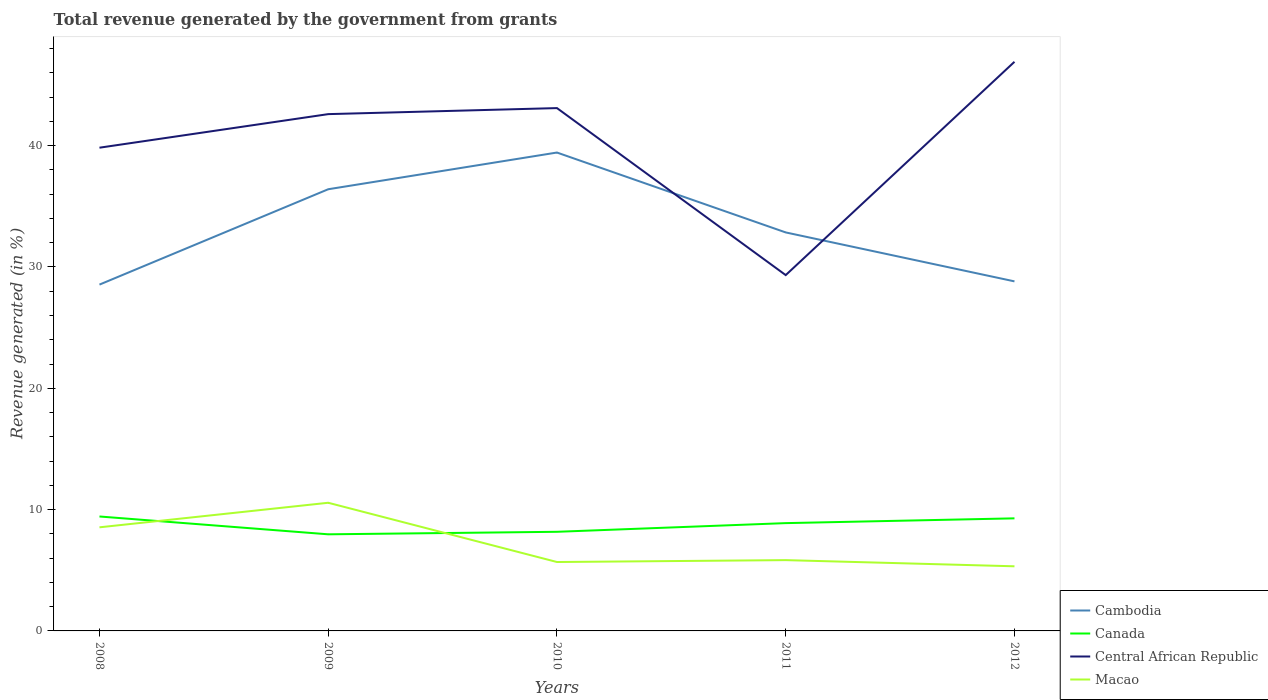Is the number of lines equal to the number of legend labels?
Give a very brief answer. Yes. Across all years, what is the maximum total revenue generated in Macao?
Provide a short and direct response. 5.33. What is the total total revenue generated in Macao in the graph?
Provide a succinct answer. 2.7. What is the difference between the highest and the second highest total revenue generated in Macao?
Your answer should be very brief. 5.24. What is the difference between the highest and the lowest total revenue generated in Cambodia?
Make the answer very short. 2. Is the total revenue generated in Central African Republic strictly greater than the total revenue generated in Canada over the years?
Offer a terse response. No. How many lines are there?
Your answer should be compact. 4. How many years are there in the graph?
Your response must be concise. 5. Are the values on the major ticks of Y-axis written in scientific E-notation?
Make the answer very short. No. Does the graph contain any zero values?
Ensure brevity in your answer.  No. Where does the legend appear in the graph?
Offer a terse response. Bottom right. What is the title of the graph?
Keep it short and to the point. Total revenue generated by the government from grants. What is the label or title of the X-axis?
Give a very brief answer. Years. What is the label or title of the Y-axis?
Ensure brevity in your answer.  Revenue generated (in %). What is the Revenue generated (in %) of Cambodia in 2008?
Your answer should be very brief. 28.55. What is the Revenue generated (in %) in Canada in 2008?
Provide a succinct answer. 9.43. What is the Revenue generated (in %) of Central African Republic in 2008?
Keep it short and to the point. 39.83. What is the Revenue generated (in %) in Macao in 2008?
Make the answer very short. 8.54. What is the Revenue generated (in %) of Cambodia in 2009?
Offer a terse response. 36.41. What is the Revenue generated (in %) in Canada in 2009?
Your response must be concise. 7.96. What is the Revenue generated (in %) of Central African Republic in 2009?
Offer a terse response. 42.6. What is the Revenue generated (in %) of Macao in 2009?
Give a very brief answer. 10.56. What is the Revenue generated (in %) in Cambodia in 2010?
Give a very brief answer. 39.43. What is the Revenue generated (in %) in Canada in 2010?
Give a very brief answer. 8.17. What is the Revenue generated (in %) in Central African Republic in 2010?
Keep it short and to the point. 43.1. What is the Revenue generated (in %) in Macao in 2010?
Keep it short and to the point. 5.68. What is the Revenue generated (in %) of Cambodia in 2011?
Keep it short and to the point. 32.85. What is the Revenue generated (in %) of Canada in 2011?
Provide a short and direct response. 8.89. What is the Revenue generated (in %) in Central African Republic in 2011?
Ensure brevity in your answer.  29.33. What is the Revenue generated (in %) of Macao in 2011?
Your answer should be compact. 5.84. What is the Revenue generated (in %) in Cambodia in 2012?
Provide a short and direct response. 28.81. What is the Revenue generated (in %) in Canada in 2012?
Make the answer very short. 9.28. What is the Revenue generated (in %) in Central African Republic in 2012?
Offer a very short reply. 46.91. What is the Revenue generated (in %) of Macao in 2012?
Provide a short and direct response. 5.33. Across all years, what is the maximum Revenue generated (in %) in Cambodia?
Provide a succinct answer. 39.43. Across all years, what is the maximum Revenue generated (in %) in Canada?
Ensure brevity in your answer.  9.43. Across all years, what is the maximum Revenue generated (in %) in Central African Republic?
Offer a very short reply. 46.91. Across all years, what is the maximum Revenue generated (in %) in Macao?
Keep it short and to the point. 10.56. Across all years, what is the minimum Revenue generated (in %) in Cambodia?
Offer a very short reply. 28.55. Across all years, what is the minimum Revenue generated (in %) of Canada?
Ensure brevity in your answer.  7.96. Across all years, what is the minimum Revenue generated (in %) of Central African Republic?
Offer a terse response. 29.33. Across all years, what is the minimum Revenue generated (in %) of Macao?
Your answer should be compact. 5.33. What is the total Revenue generated (in %) of Cambodia in the graph?
Provide a succinct answer. 166.05. What is the total Revenue generated (in %) in Canada in the graph?
Your answer should be compact. 43.73. What is the total Revenue generated (in %) in Central African Republic in the graph?
Give a very brief answer. 201.78. What is the total Revenue generated (in %) in Macao in the graph?
Keep it short and to the point. 35.95. What is the difference between the Revenue generated (in %) of Cambodia in 2008 and that in 2009?
Offer a very short reply. -7.86. What is the difference between the Revenue generated (in %) of Canada in 2008 and that in 2009?
Keep it short and to the point. 1.47. What is the difference between the Revenue generated (in %) in Central African Republic in 2008 and that in 2009?
Your answer should be compact. -2.77. What is the difference between the Revenue generated (in %) of Macao in 2008 and that in 2009?
Offer a terse response. -2.02. What is the difference between the Revenue generated (in %) of Cambodia in 2008 and that in 2010?
Offer a terse response. -10.89. What is the difference between the Revenue generated (in %) in Canada in 2008 and that in 2010?
Offer a terse response. 1.26. What is the difference between the Revenue generated (in %) in Central African Republic in 2008 and that in 2010?
Offer a terse response. -3.26. What is the difference between the Revenue generated (in %) of Macao in 2008 and that in 2010?
Ensure brevity in your answer.  2.86. What is the difference between the Revenue generated (in %) in Cambodia in 2008 and that in 2011?
Keep it short and to the point. -4.3. What is the difference between the Revenue generated (in %) in Canada in 2008 and that in 2011?
Keep it short and to the point. 0.55. What is the difference between the Revenue generated (in %) in Central African Republic in 2008 and that in 2011?
Offer a very short reply. 10.5. What is the difference between the Revenue generated (in %) in Macao in 2008 and that in 2011?
Provide a succinct answer. 2.7. What is the difference between the Revenue generated (in %) in Cambodia in 2008 and that in 2012?
Your response must be concise. -0.27. What is the difference between the Revenue generated (in %) of Canada in 2008 and that in 2012?
Your answer should be very brief. 0.15. What is the difference between the Revenue generated (in %) in Central African Republic in 2008 and that in 2012?
Make the answer very short. -7.08. What is the difference between the Revenue generated (in %) in Macao in 2008 and that in 2012?
Ensure brevity in your answer.  3.21. What is the difference between the Revenue generated (in %) in Cambodia in 2009 and that in 2010?
Your answer should be very brief. -3.03. What is the difference between the Revenue generated (in %) of Canada in 2009 and that in 2010?
Ensure brevity in your answer.  -0.21. What is the difference between the Revenue generated (in %) in Central African Republic in 2009 and that in 2010?
Your answer should be very brief. -0.5. What is the difference between the Revenue generated (in %) in Macao in 2009 and that in 2010?
Your answer should be compact. 4.88. What is the difference between the Revenue generated (in %) of Cambodia in 2009 and that in 2011?
Your answer should be compact. 3.56. What is the difference between the Revenue generated (in %) in Canada in 2009 and that in 2011?
Offer a very short reply. -0.92. What is the difference between the Revenue generated (in %) of Central African Republic in 2009 and that in 2011?
Give a very brief answer. 13.27. What is the difference between the Revenue generated (in %) of Macao in 2009 and that in 2011?
Give a very brief answer. 4.73. What is the difference between the Revenue generated (in %) of Cambodia in 2009 and that in 2012?
Your response must be concise. 7.59. What is the difference between the Revenue generated (in %) of Canada in 2009 and that in 2012?
Ensure brevity in your answer.  -1.32. What is the difference between the Revenue generated (in %) of Central African Republic in 2009 and that in 2012?
Give a very brief answer. -4.31. What is the difference between the Revenue generated (in %) in Macao in 2009 and that in 2012?
Keep it short and to the point. 5.24. What is the difference between the Revenue generated (in %) in Cambodia in 2010 and that in 2011?
Your response must be concise. 6.59. What is the difference between the Revenue generated (in %) of Canada in 2010 and that in 2011?
Offer a very short reply. -0.72. What is the difference between the Revenue generated (in %) in Central African Republic in 2010 and that in 2011?
Your answer should be very brief. 13.77. What is the difference between the Revenue generated (in %) in Macao in 2010 and that in 2011?
Provide a succinct answer. -0.16. What is the difference between the Revenue generated (in %) of Cambodia in 2010 and that in 2012?
Your response must be concise. 10.62. What is the difference between the Revenue generated (in %) of Canada in 2010 and that in 2012?
Your answer should be very brief. -1.11. What is the difference between the Revenue generated (in %) in Central African Republic in 2010 and that in 2012?
Your answer should be very brief. -3.82. What is the difference between the Revenue generated (in %) of Macao in 2010 and that in 2012?
Provide a short and direct response. 0.35. What is the difference between the Revenue generated (in %) in Cambodia in 2011 and that in 2012?
Offer a very short reply. 4.03. What is the difference between the Revenue generated (in %) of Canada in 2011 and that in 2012?
Give a very brief answer. -0.39. What is the difference between the Revenue generated (in %) in Central African Republic in 2011 and that in 2012?
Offer a terse response. -17.58. What is the difference between the Revenue generated (in %) in Macao in 2011 and that in 2012?
Give a very brief answer. 0.51. What is the difference between the Revenue generated (in %) in Cambodia in 2008 and the Revenue generated (in %) in Canada in 2009?
Provide a short and direct response. 20.58. What is the difference between the Revenue generated (in %) in Cambodia in 2008 and the Revenue generated (in %) in Central African Republic in 2009?
Your answer should be very brief. -14.05. What is the difference between the Revenue generated (in %) of Cambodia in 2008 and the Revenue generated (in %) of Macao in 2009?
Make the answer very short. 17.98. What is the difference between the Revenue generated (in %) in Canada in 2008 and the Revenue generated (in %) in Central African Republic in 2009?
Provide a succinct answer. -33.17. What is the difference between the Revenue generated (in %) of Canada in 2008 and the Revenue generated (in %) of Macao in 2009?
Your answer should be very brief. -1.13. What is the difference between the Revenue generated (in %) in Central African Republic in 2008 and the Revenue generated (in %) in Macao in 2009?
Keep it short and to the point. 29.27. What is the difference between the Revenue generated (in %) in Cambodia in 2008 and the Revenue generated (in %) in Canada in 2010?
Provide a succinct answer. 20.38. What is the difference between the Revenue generated (in %) of Cambodia in 2008 and the Revenue generated (in %) of Central African Republic in 2010?
Your answer should be compact. -14.55. What is the difference between the Revenue generated (in %) of Cambodia in 2008 and the Revenue generated (in %) of Macao in 2010?
Provide a short and direct response. 22.87. What is the difference between the Revenue generated (in %) of Canada in 2008 and the Revenue generated (in %) of Central African Republic in 2010?
Ensure brevity in your answer.  -33.67. What is the difference between the Revenue generated (in %) of Canada in 2008 and the Revenue generated (in %) of Macao in 2010?
Your answer should be compact. 3.75. What is the difference between the Revenue generated (in %) in Central African Republic in 2008 and the Revenue generated (in %) in Macao in 2010?
Provide a short and direct response. 34.15. What is the difference between the Revenue generated (in %) of Cambodia in 2008 and the Revenue generated (in %) of Canada in 2011?
Offer a terse response. 19.66. What is the difference between the Revenue generated (in %) in Cambodia in 2008 and the Revenue generated (in %) in Central African Republic in 2011?
Ensure brevity in your answer.  -0.78. What is the difference between the Revenue generated (in %) of Cambodia in 2008 and the Revenue generated (in %) of Macao in 2011?
Keep it short and to the point. 22.71. What is the difference between the Revenue generated (in %) in Canada in 2008 and the Revenue generated (in %) in Central African Republic in 2011?
Make the answer very short. -19.9. What is the difference between the Revenue generated (in %) of Canada in 2008 and the Revenue generated (in %) of Macao in 2011?
Make the answer very short. 3.6. What is the difference between the Revenue generated (in %) in Central African Republic in 2008 and the Revenue generated (in %) in Macao in 2011?
Your answer should be compact. 34. What is the difference between the Revenue generated (in %) in Cambodia in 2008 and the Revenue generated (in %) in Canada in 2012?
Your response must be concise. 19.27. What is the difference between the Revenue generated (in %) in Cambodia in 2008 and the Revenue generated (in %) in Central African Republic in 2012?
Your response must be concise. -18.37. What is the difference between the Revenue generated (in %) in Cambodia in 2008 and the Revenue generated (in %) in Macao in 2012?
Make the answer very short. 23.22. What is the difference between the Revenue generated (in %) of Canada in 2008 and the Revenue generated (in %) of Central African Republic in 2012?
Offer a terse response. -37.48. What is the difference between the Revenue generated (in %) in Canada in 2008 and the Revenue generated (in %) in Macao in 2012?
Your answer should be compact. 4.11. What is the difference between the Revenue generated (in %) in Central African Republic in 2008 and the Revenue generated (in %) in Macao in 2012?
Provide a succinct answer. 34.51. What is the difference between the Revenue generated (in %) in Cambodia in 2009 and the Revenue generated (in %) in Canada in 2010?
Keep it short and to the point. 28.24. What is the difference between the Revenue generated (in %) in Cambodia in 2009 and the Revenue generated (in %) in Central African Republic in 2010?
Ensure brevity in your answer.  -6.69. What is the difference between the Revenue generated (in %) in Cambodia in 2009 and the Revenue generated (in %) in Macao in 2010?
Your answer should be compact. 30.73. What is the difference between the Revenue generated (in %) of Canada in 2009 and the Revenue generated (in %) of Central African Republic in 2010?
Offer a terse response. -35.14. What is the difference between the Revenue generated (in %) of Canada in 2009 and the Revenue generated (in %) of Macao in 2010?
Ensure brevity in your answer.  2.28. What is the difference between the Revenue generated (in %) of Central African Republic in 2009 and the Revenue generated (in %) of Macao in 2010?
Give a very brief answer. 36.92. What is the difference between the Revenue generated (in %) in Cambodia in 2009 and the Revenue generated (in %) in Canada in 2011?
Give a very brief answer. 27.52. What is the difference between the Revenue generated (in %) in Cambodia in 2009 and the Revenue generated (in %) in Central African Republic in 2011?
Offer a terse response. 7.08. What is the difference between the Revenue generated (in %) of Cambodia in 2009 and the Revenue generated (in %) of Macao in 2011?
Your answer should be very brief. 30.57. What is the difference between the Revenue generated (in %) of Canada in 2009 and the Revenue generated (in %) of Central African Republic in 2011?
Give a very brief answer. -21.37. What is the difference between the Revenue generated (in %) of Canada in 2009 and the Revenue generated (in %) of Macao in 2011?
Your response must be concise. 2.13. What is the difference between the Revenue generated (in %) in Central African Republic in 2009 and the Revenue generated (in %) in Macao in 2011?
Provide a short and direct response. 36.76. What is the difference between the Revenue generated (in %) in Cambodia in 2009 and the Revenue generated (in %) in Canada in 2012?
Offer a terse response. 27.13. What is the difference between the Revenue generated (in %) of Cambodia in 2009 and the Revenue generated (in %) of Central African Republic in 2012?
Your answer should be compact. -10.51. What is the difference between the Revenue generated (in %) in Cambodia in 2009 and the Revenue generated (in %) in Macao in 2012?
Offer a very short reply. 31.08. What is the difference between the Revenue generated (in %) of Canada in 2009 and the Revenue generated (in %) of Central African Republic in 2012?
Provide a short and direct response. -38.95. What is the difference between the Revenue generated (in %) in Canada in 2009 and the Revenue generated (in %) in Macao in 2012?
Provide a short and direct response. 2.64. What is the difference between the Revenue generated (in %) in Central African Republic in 2009 and the Revenue generated (in %) in Macao in 2012?
Your answer should be very brief. 37.27. What is the difference between the Revenue generated (in %) of Cambodia in 2010 and the Revenue generated (in %) of Canada in 2011?
Ensure brevity in your answer.  30.55. What is the difference between the Revenue generated (in %) in Cambodia in 2010 and the Revenue generated (in %) in Central African Republic in 2011?
Provide a short and direct response. 10.1. What is the difference between the Revenue generated (in %) in Cambodia in 2010 and the Revenue generated (in %) in Macao in 2011?
Provide a succinct answer. 33.6. What is the difference between the Revenue generated (in %) in Canada in 2010 and the Revenue generated (in %) in Central African Republic in 2011?
Provide a succinct answer. -21.16. What is the difference between the Revenue generated (in %) of Canada in 2010 and the Revenue generated (in %) of Macao in 2011?
Provide a short and direct response. 2.33. What is the difference between the Revenue generated (in %) in Central African Republic in 2010 and the Revenue generated (in %) in Macao in 2011?
Ensure brevity in your answer.  37.26. What is the difference between the Revenue generated (in %) in Cambodia in 2010 and the Revenue generated (in %) in Canada in 2012?
Offer a very short reply. 30.15. What is the difference between the Revenue generated (in %) of Cambodia in 2010 and the Revenue generated (in %) of Central African Republic in 2012?
Ensure brevity in your answer.  -7.48. What is the difference between the Revenue generated (in %) of Cambodia in 2010 and the Revenue generated (in %) of Macao in 2012?
Your response must be concise. 34.11. What is the difference between the Revenue generated (in %) in Canada in 2010 and the Revenue generated (in %) in Central African Republic in 2012?
Your answer should be very brief. -38.74. What is the difference between the Revenue generated (in %) in Canada in 2010 and the Revenue generated (in %) in Macao in 2012?
Give a very brief answer. 2.84. What is the difference between the Revenue generated (in %) of Central African Republic in 2010 and the Revenue generated (in %) of Macao in 2012?
Your answer should be compact. 37.77. What is the difference between the Revenue generated (in %) of Cambodia in 2011 and the Revenue generated (in %) of Canada in 2012?
Give a very brief answer. 23.57. What is the difference between the Revenue generated (in %) in Cambodia in 2011 and the Revenue generated (in %) in Central African Republic in 2012?
Ensure brevity in your answer.  -14.07. What is the difference between the Revenue generated (in %) in Cambodia in 2011 and the Revenue generated (in %) in Macao in 2012?
Offer a terse response. 27.52. What is the difference between the Revenue generated (in %) of Canada in 2011 and the Revenue generated (in %) of Central African Republic in 2012?
Your answer should be compact. -38.03. What is the difference between the Revenue generated (in %) in Canada in 2011 and the Revenue generated (in %) in Macao in 2012?
Offer a terse response. 3.56. What is the difference between the Revenue generated (in %) of Central African Republic in 2011 and the Revenue generated (in %) of Macao in 2012?
Your response must be concise. 24. What is the average Revenue generated (in %) in Cambodia per year?
Give a very brief answer. 33.21. What is the average Revenue generated (in %) of Canada per year?
Ensure brevity in your answer.  8.75. What is the average Revenue generated (in %) in Central African Republic per year?
Your response must be concise. 40.36. What is the average Revenue generated (in %) in Macao per year?
Your response must be concise. 7.19. In the year 2008, what is the difference between the Revenue generated (in %) of Cambodia and Revenue generated (in %) of Canada?
Offer a very short reply. 19.11. In the year 2008, what is the difference between the Revenue generated (in %) of Cambodia and Revenue generated (in %) of Central African Republic?
Your response must be concise. -11.29. In the year 2008, what is the difference between the Revenue generated (in %) in Cambodia and Revenue generated (in %) in Macao?
Make the answer very short. 20.01. In the year 2008, what is the difference between the Revenue generated (in %) of Canada and Revenue generated (in %) of Central African Republic?
Ensure brevity in your answer.  -30.4. In the year 2008, what is the difference between the Revenue generated (in %) in Canada and Revenue generated (in %) in Macao?
Your answer should be very brief. 0.89. In the year 2008, what is the difference between the Revenue generated (in %) of Central African Republic and Revenue generated (in %) of Macao?
Provide a short and direct response. 31.29. In the year 2009, what is the difference between the Revenue generated (in %) of Cambodia and Revenue generated (in %) of Canada?
Ensure brevity in your answer.  28.45. In the year 2009, what is the difference between the Revenue generated (in %) of Cambodia and Revenue generated (in %) of Central African Republic?
Provide a succinct answer. -6.19. In the year 2009, what is the difference between the Revenue generated (in %) of Cambodia and Revenue generated (in %) of Macao?
Give a very brief answer. 25.84. In the year 2009, what is the difference between the Revenue generated (in %) in Canada and Revenue generated (in %) in Central African Republic?
Offer a terse response. -34.64. In the year 2009, what is the difference between the Revenue generated (in %) in Canada and Revenue generated (in %) in Macao?
Offer a very short reply. -2.6. In the year 2009, what is the difference between the Revenue generated (in %) of Central African Republic and Revenue generated (in %) of Macao?
Offer a very short reply. 32.04. In the year 2010, what is the difference between the Revenue generated (in %) of Cambodia and Revenue generated (in %) of Canada?
Make the answer very short. 31.26. In the year 2010, what is the difference between the Revenue generated (in %) in Cambodia and Revenue generated (in %) in Central African Republic?
Offer a very short reply. -3.66. In the year 2010, what is the difference between the Revenue generated (in %) in Cambodia and Revenue generated (in %) in Macao?
Provide a short and direct response. 33.75. In the year 2010, what is the difference between the Revenue generated (in %) in Canada and Revenue generated (in %) in Central African Republic?
Ensure brevity in your answer.  -34.93. In the year 2010, what is the difference between the Revenue generated (in %) of Canada and Revenue generated (in %) of Macao?
Ensure brevity in your answer.  2.49. In the year 2010, what is the difference between the Revenue generated (in %) of Central African Republic and Revenue generated (in %) of Macao?
Give a very brief answer. 37.42. In the year 2011, what is the difference between the Revenue generated (in %) in Cambodia and Revenue generated (in %) in Canada?
Provide a succinct answer. 23.96. In the year 2011, what is the difference between the Revenue generated (in %) of Cambodia and Revenue generated (in %) of Central African Republic?
Your answer should be very brief. 3.52. In the year 2011, what is the difference between the Revenue generated (in %) of Cambodia and Revenue generated (in %) of Macao?
Your response must be concise. 27.01. In the year 2011, what is the difference between the Revenue generated (in %) of Canada and Revenue generated (in %) of Central African Republic?
Offer a very short reply. -20.44. In the year 2011, what is the difference between the Revenue generated (in %) of Canada and Revenue generated (in %) of Macao?
Offer a very short reply. 3.05. In the year 2011, what is the difference between the Revenue generated (in %) in Central African Republic and Revenue generated (in %) in Macao?
Provide a succinct answer. 23.5. In the year 2012, what is the difference between the Revenue generated (in %) in Cambodia and Revenue generated (in %) in Canada?
Offer a very short reply. 19.53. In the year 2012, what is the difference between the Revenue generated (in %) of Cambodia and Revenue generated (in %) of Central African Republic?
Provide a succinct answer. -18.1. In the year 2012, what is the difference between the Revenue generated (in %) in Cambodia and Revenue generated (in %) in Macao?
Your response must be concise. 23.49. In the year 2012, what is the difference between the Revenue generated (in %) in Canada and Revenue generated (in %) in Central African Republic?
Provide a succinct answer. -37.63. In the year 2012, what is the difference between the Revenue generated (in %) of Canada and Revenue generated (in %) of Macao?
Your answer should be very brief. 3.95. In the year 2012, what is the difference between the Revenue generated (in %) in Central African Republic and Revenue generated (in %) in Macao?
Your answer should be compact. 41.59. What is the ratio of the Revenue generated (in %) of Cambodia in 2008 to that in 2009?
Offer a terse response. 0.78. What is the ratio of the Revenue generated (in %) in Canada in 2008 to that in 2009?
Ensure brevity in your answer.  1.18. What is the ratio of the Revenue generated (in %) of Central African Republic in 2008 to that in 2009?
Offer a very short reply. 0.94. What is the ratio of the Revenue generated (in %) in Macao in 2008 to that in 2009?
Provide a short and direct response. 0.81. What is the ratio of the Revenue generated (in %) of Cambodia in 2008 to that in 2010?
Provide a short and direct response. 0.72. What is the ratio of the Revenue generated (in %) of Canada in 2008 to that in 2010?
Ensure brevity in your answer.  1.15. What is the ratio of the Revenue generated (in %) of Central African Republic in 2008 to that in 2010?
Make the answer very short. 0.92. What is the ratio of the Revenue generated (in %) in Macao in 2008 to that in 2010?
Your response must be concise. 1.5. What is the ratio of the Revenue generated (in %) in Cambodia in 2008 to that in 2011?
Keep it short and to the point. 0.87. What is the ratio of the Revenue generated (in %) in Canada in 2008 to that in 2011?
Make the answer very short. 1.06. What is the ratio of the Revenue generated (in %) in Central African Republic in 2008 to that in 2011?
Provide a succinct answer. 1.36. What is the ratio of the Revenue generated (in %) in Macao in 2008 to that in 2011?
Provide a short and direct response. 1.46. What is the ratio of the Revenue generated (in %) in Cambodia in 2008 to that in 2012?
Offer a terse response. 0.99. What is the ratio of the Revenue generated (in %) in Canada in 2008 to that in 2012?
Ensure brevity in your answer.  1.02. What is the ratio of the Revenue generated (in %) of Central African Republic in 2008 to that in 2012?
Provide a succinct answer. 0.85. What is the ratio of the Revenue generated (in %) in Macao in 2008 to that in 2012?
Your answer should be compact. 1.6. What is the ratio of the Revenue generated (in %) in Cambodia in 2009 to that in 2010?
Give a very brief answer. 0.92. What is the ratio of the Revenue generated (in %) in Canada in 2009 to that in 2010?
Provide a short and direct response. 0.97. What is the ratio of the Revenue generated (in %) of Central African Republic in 2009 to that in 2010?
Provide a succinct answer. 0.99. What is the ratio of the Revenue generated (in %) in Macao in 2009 to that in 2010?
Your answer should be compact. 1.86. What is the ratio of the Revenue generated (in %) in Cambodia in 2009 to that in 2011?
Make the answer very short. 1.11. What is the ratio of the Revenue generated (in %) in Canada in 2009 to that in 2011?
Give a very brief answer. 0.9. What is the ratio of the Revenue generated (in %) in Central African Republic in 2009 to that in 2011?
Provide a short and direct response. 1.45. What is the ratio of the Revenue generated (in %) in Macao in 2009 to that in 2011?
Offer a terse response. 1.81. What is the ratio of the Revenue generated (in %) in Cambodia in 2009 to that in 2012?
Ensure brevity in your answer.  1.26. What is the ratio of the Revenue generated (in %) of Canada in 2009 to that in 2012?
Ensure brevity in your answer.  0.86. What is the ratio of the Revenue generated (in %) of Central African Republic in 2009 to that in 2012?
Provide a succinct answer. 0.91. What is the ratio of the Revenue generated (in %) of Macao in 2009 to that in 2012?
Your answer should be compact. 1.98. What is the ratio of the Revenue generated (in %) in Cambodia in 2010 to that in 2011?
Provide a succinct answer. 1.2. What is the ratio of the Revenue generated (in %) of Canada in 2010 to that in 2011?
Make the answer very short. 0.92. What is the ratio of the Revenue generated (in %) in Central African Republic in 2010 to that in 2011?
Your answer should be very brief. 1.47. What is the ratio of the Revenue generated (in %) in Macao in 2010 to that in 2011?
Ensure brevity in your answer.  0.97. What is the ratio of the Revenue generated (in %) in Cambodia in 2010 to that in 2012?
Provide a short and direct response. 1.37. What is the ratio of the Revenue generated (in %) of Canada in 2010 to that in 2012?
Your answer should be compact. 0.88. What is the ratio of the Revenue generated (in %) of Central African Republic in 2010 to that in 2012?
Your answer should be compact. 0.92. What is the ratio of the Revenue generated (in %) in Macao in 2010 to that in 2012?
Make the answer very short. 1.07. What is the ratio of the Revenue generated (in %) of Cambodia in 2011 to that in 2012?
Your answer should be very brief. 1.14. What is the ratio of the Revenue generated (in %) of Canada in 2011 to that in 2012?
Your answer should be compact. 0.96. What is the ratio of the Revenue generated (in %) in Central African Republic in 2011 to that in 2012?
Your answer should be compact. 0.63. What is the ratio of the Revenue generated (in %) of Macao in 2011 to that in 2012?
Offer a terse response. 1.1. What is the difference between the highest and the second highest Revenue generated (in %) in Cambodia?
Provide a short and direct response. 3.03. What is the difference between the highest and the second highest Revenue generated (in %) of Canada?
Your answer should be very brief. 0.15. What is the difference between the highest and the second highest Revenue generated (in %) in Central African Republic?
Your answer should be very brief. 3.82. What is the difference between the highest and the second highest Revenue generated (in %) of Macao?
Offer a terse response. 2.02. What is the difference between the highest and the lowest Revenue generated (in %) of Cambodia?
Provide a short and direct response. 10.89. What is the difference between the highest and the lowest Revenue generated (in %) in Canada?
Make the answer very short. 1.47. What is the difference between the highest and the lowest Revenue generated (in %) of Central African Republic?
Ensure brevity in your answer.  17.58. What is the difference between the highest and the lowest Revenue generated (in %) in Macao?
Ensure brevity in your answer.  5.24. 